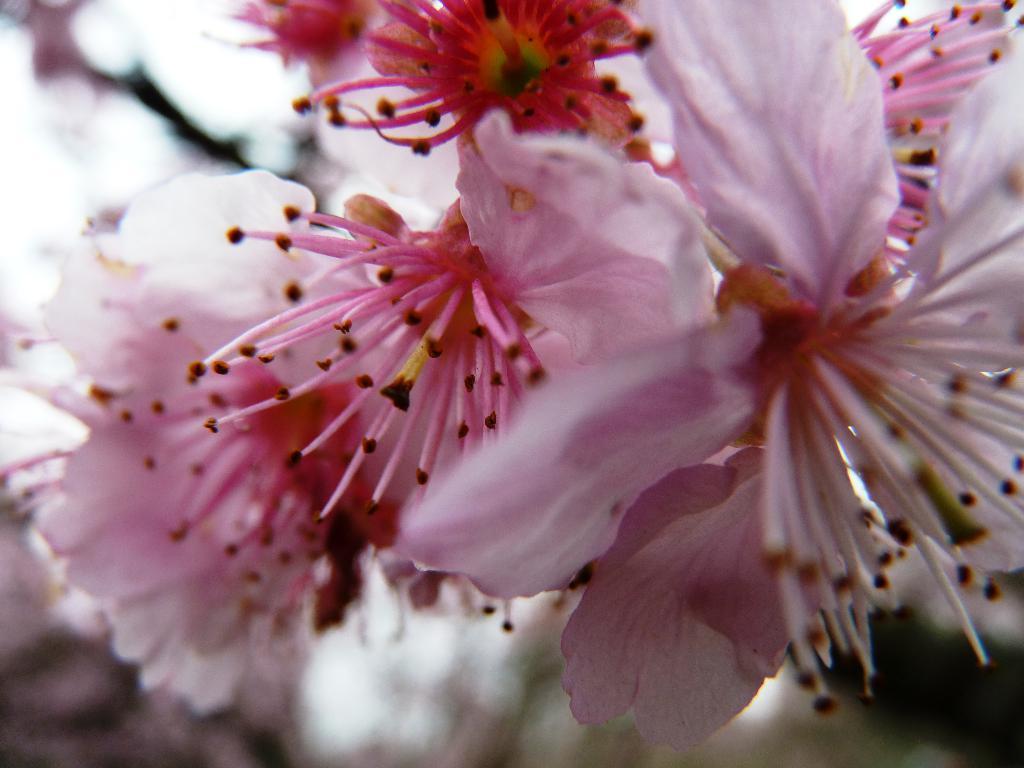Can you describe this image briefly? In the picture we can see some flowers which are pink in color. 